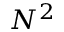<formula> <loc_0><loc_0><loc_500><loc_500>N ^ { 2 }</formula> 